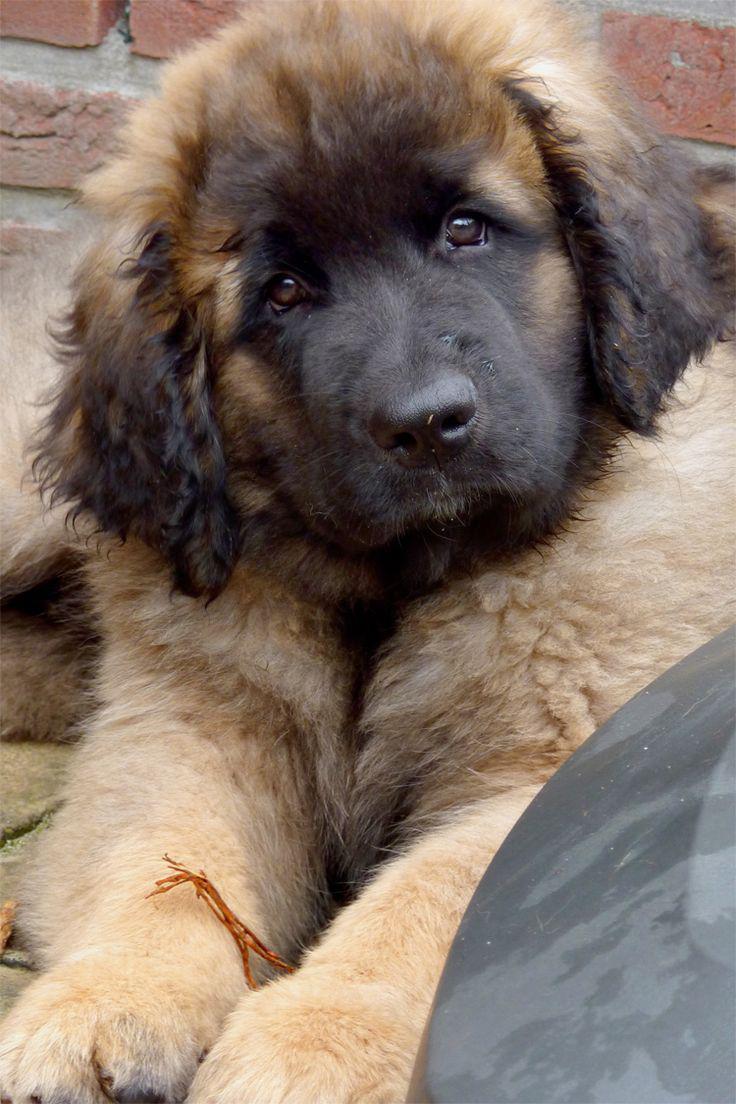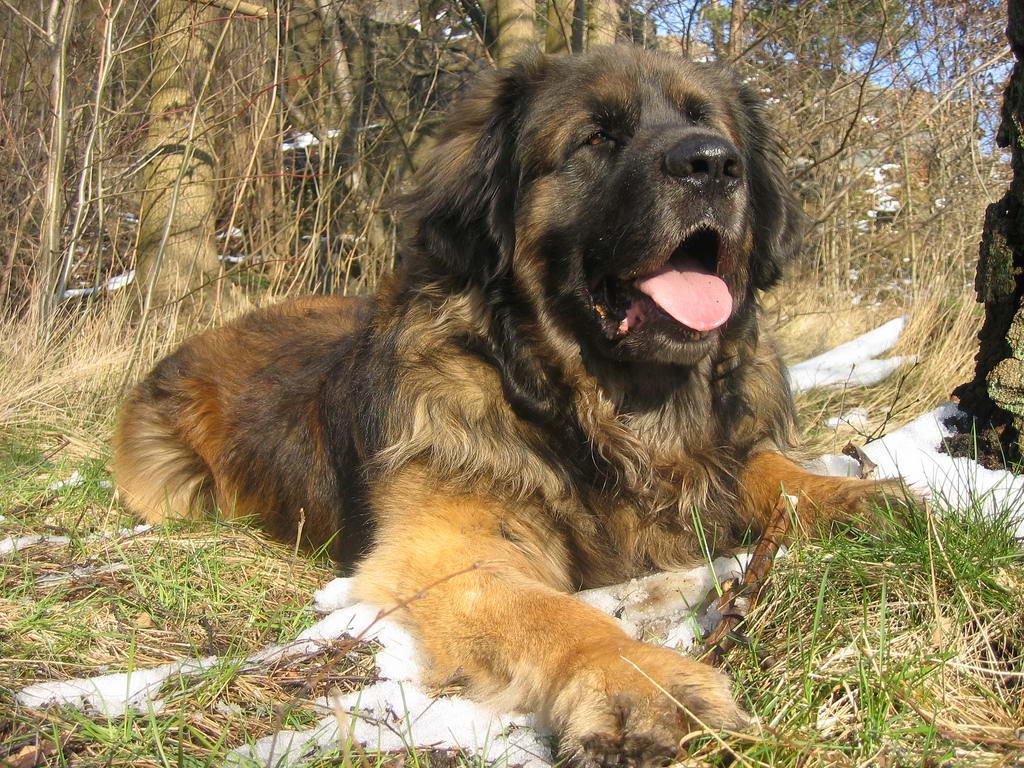The first image is the image on the left, the second image is the image on the right. Examine the images to the left and right. Is the description "There are three dogs" accurate? Answer yes or no. No. 